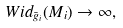Convert formula to latex. <formula><loc_0><loc_0><loc_500><loc_500>W i d _ { \bar { g } _ { i } } ( M _ { i } ) \rightarrow \infty ,</formula> 